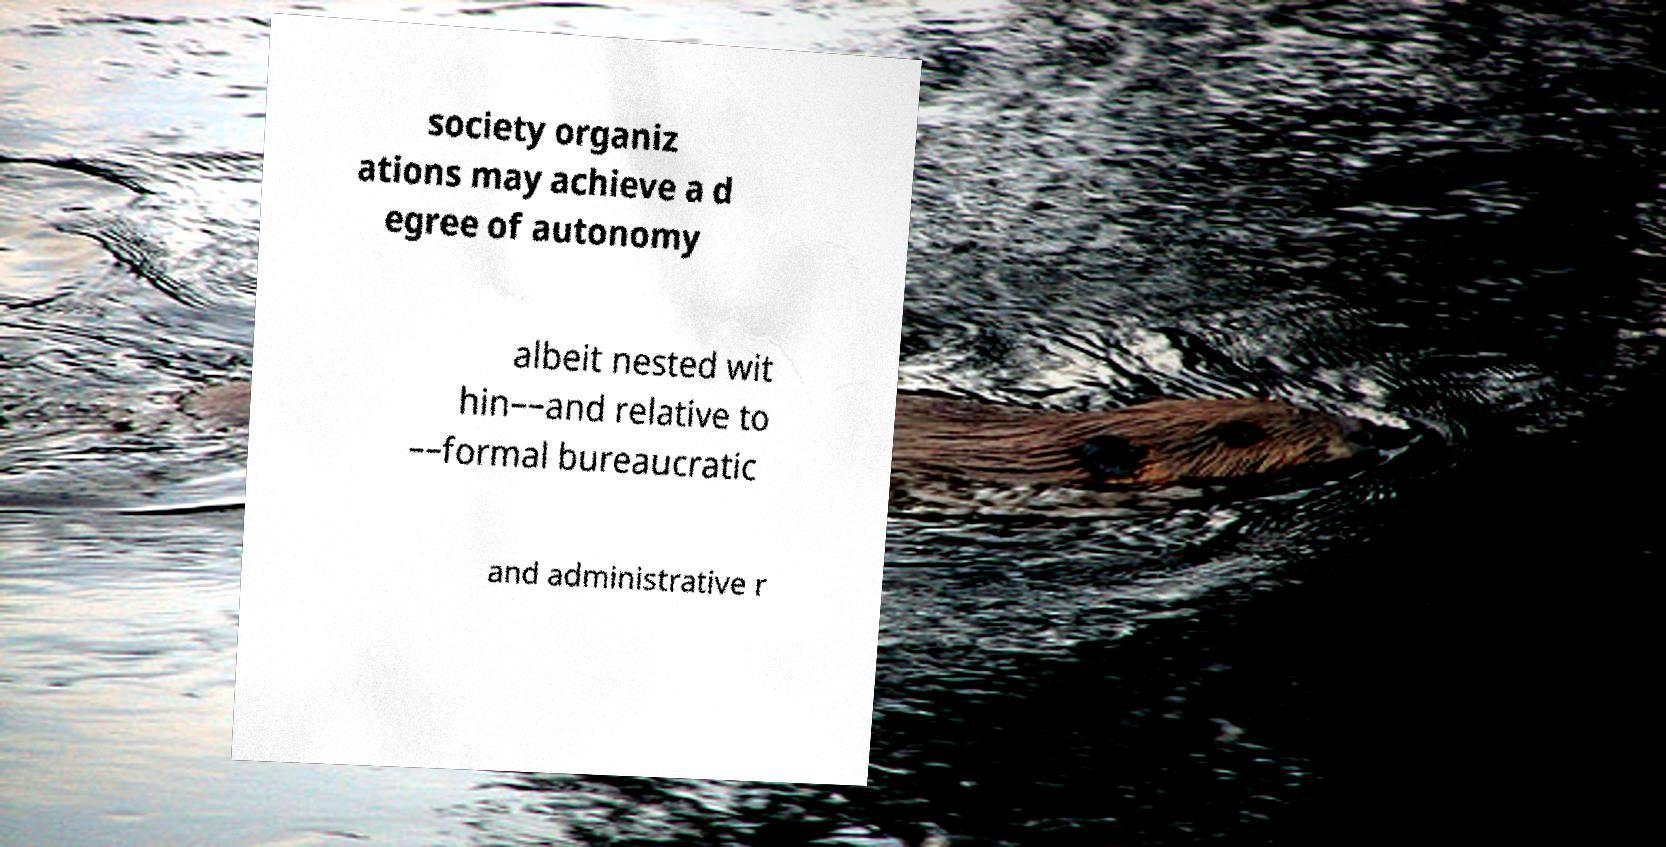Please identify and transcribe the text found in this image. society organiz ations may achieve a d egree of autonomy albeit nested wit hin––and relative to ––formal bureaucratic and administrative r 